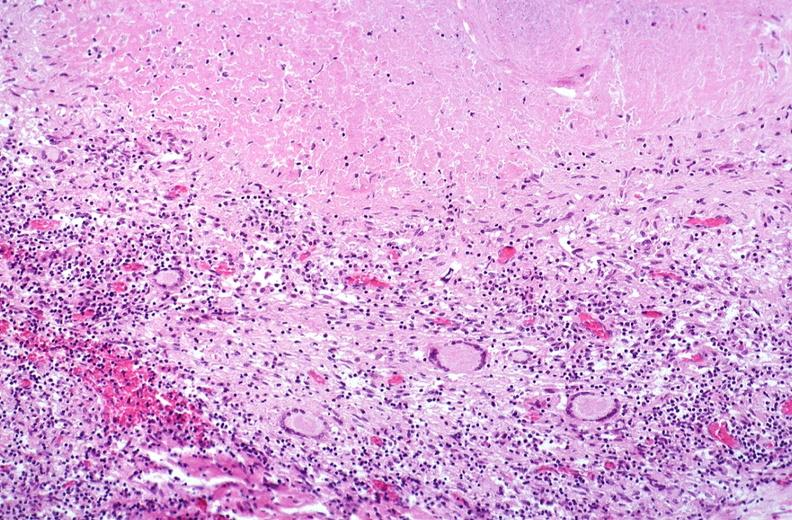s fracture present?
Answer the question using a single word or phrase. No 